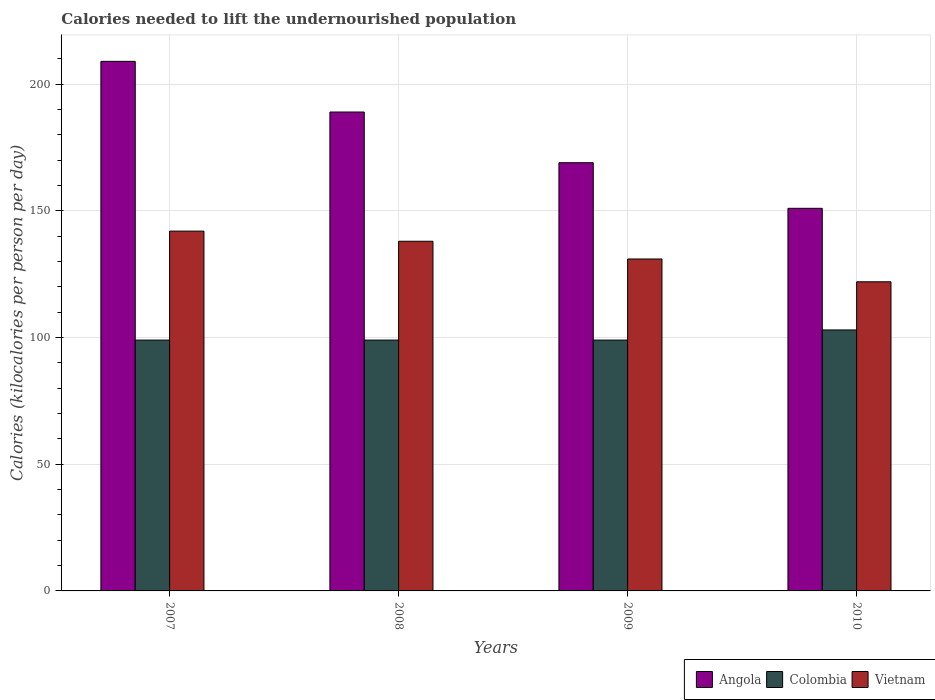How many different coloured bars are there?
Provide a succinct answer. 3. How many groups of bars are there?
Provide a short and direct response. 4. What is the label of the 3rd group of bars from the left?
Offer a terse response. 2009. In how many cases, is the number of bars for a given year not equal to the number of legend labels?
Provide a succinct answer. 0. What is the total calories needed to lift the undernourished population in Angola in 2009?
Ensure brevity in your answer.  169. Across all years, what is the maximum total calories needed to lift the undernourished population in Colombia?
Keep it short and to the point. 103. Across all years, what is the minimum total calories needed to lift the undernourished population in Vietnam?
Provide a short and direct response. 122. In which year was the total calories needed to lift the undernourished population in Angola maximum?
Your answer should be compact. 2007. In which year was the total calories needed to lift the undernourished population in Vietnam minimum?
Provide a succinct answer. 2010. What is the total total calories needed to lift the undernourished population in Vietnam in the graph?
Your response must be concise. 533. What is the difference between the total calories needed to lift the undernourished population in Vietnam in 2008 and that in 2009?
Your answer should be very brief. 7. What is the difference between the total calories needed to lift the undernourished population in Vietnam in 2007 and the total calories needed to lift the undernourished population in Angola in 2010?
Offer a terse response. -9. What is the average total calories needed to lift the undernourished population in Angola per year?
Give a very brief answer. 179.5. In the year 2008, what is the difference between the total calories needed to lift the undernourished population in Angola and total calories needed to lift the undernourished population in Vietnam?
Your answer should be very brief. 51. In how many years, is the total calories needed to lift the undernourished population in Angola greater than 160 kilocalories?
Keep it short and to the point. 3. What is the ratio of the total calories needed to lift the undernourished population in Colombia in 2008 to that in 2010?
Your answer should be compact. 0.96. Is the difference between the total calories needed to lift the undernourished population in Angola in 2009 and 2010 greater than the difference between the total calories needed to lift the undernourished population in Vietnam in 2009 and 2010?
Make the answer very short. Yes. What is the difference between the highest and the second highest total calories needed to lift the undernourished population in Angola?
Give a very brief answer. 20. What is the difference between the highest and the lowest total calories needed to lift the undernourished population in Vietnam?
Keep it short and to the point. 20. What does the 1st bar from the left in 2007 represents?
Keep it short and to the point. Angola. Is it the case that in every year, the sum of the total calories needed to lift the undernourished population in Vietnam and total calories needed to lift the undernourished population in Colombia is greater than the total calories needed to lift the undernourished population in Angola?
Make the answer very short. Yes. How many bars are there?
Make the answer very short. 12. Does the graph contain any zero values?
Offer a very short reply. No. Does the graph contain grids?
Provide a succinct answer. Yes. How many legend labels are there?
Your answer should be compact. 3. What is the title of the graph?
Ensure brevity in your answer.  Calories needed to lift the undernourished population. What is the label or title of the Y-axis?
Ensure brevity in your answer.  Calories (kilocalories per person per day). What is the Calories (kilocalories per person per day) in Angola in 2007?
Your response must be concise. 209. What is the Calories (kilocalories per person per day) in Vietnam in 2007?
Ensure brevity in your answer.  142. What is the Calories (kilocalories per person per day) in Angola in 2008?
Keep it short and to the point. 189. What is the Calories (kilocalories per person per day) of Colombia in 2008?
Offer a terse response. 99. What is the Calories (kilocalories per person per day) in Vietnam in 2008?
Keep it short and to the point. 138. What is the Calories (kilocalories per person per day) in Angola in 2009?
Your answer should be very brief. 169. What is the Calories (kilocalories per person per day) in Colombia in 2009?
Provide a short and direct response. 99. What is the Calories (kilocalories per person per day) in Vietnam in 2009?
Ensure brevity in your answer.  131. What is the Calories (kilocalories per person per day) in Angola in 2010?
Give a very brief answer. 151. What is the Calories (kilocalories per person per day) in Colombia in 2010?
Provide a short and direct response. 103. What is the Calories (kilocalories per person per day) in Vietnam in 2010?
Offer a very short reply. 122. Across all years, what is the maximum Calories (kilocalories per person per day) in Angola?
Keep it short and to the point. 209. Across all years, what is the maximum Calories (kilocalories per person per day) of Colombia?
Make the answer very short. 103. Across all years, what is the maximum Calories (kilocalories per person per day) of Vietnam?
Provide a succinct answer. 142. Across all years, what is the minimum Calories (kilocalories per person per day) of Angola?
Keep it short and to the point. 151. Across all years, what is the minimum Calories (kilocalories per person per day) in Colombia?
Offer a very short reply. 99. Across all years, what is the minimum Calories (kilocalories per person per day) of Vietnam?
Keep it short and to the point. 122. What is the total Calories (kilocalories per person per day) of Angola in the graph?
Give a very brief answer. 718. What is the total Calories (kilocalories per person per day) in Colombia in the graph?
Offer a very short reply. 400. What is the total Calories (kilocalories per person per day) in Vietnam in the graph?
Make the answer very short. 533. What is the difference between the Calories (kilocalories per person per day) of Angola in 2007 and that in 2008?
Provide a short and direct response. 20. What is the difference between the Calories (kilocalories per person per day) of Colombia in 2007 and that in 2008?
Make the answer very short. 0. What is the difference between the Calories (kilocalories per person per day) in Colombia in 2007 and that in 2009?
Your response must be concise. 0. What is the difference between the Calories (kilocalories per person per day) in Vietnam in 2007 and that in 2009?
Offer a terse response. 11. What is the difference between the Calories (kilocalories per person per day) of Colombia in 2007 and that in 2010?
Offer a very short reply. -4. What is the difference between the Calories (kilocalories per person per day) of Vietnam in 2007 and that in 2010?
Your response must be concise. 20. What is the difference between the Calories (kilocalories per person per day) of Vietnam in 2008 and that in 2009?
Offer a very short reply. 7. What is the difference between the Calories (kilocalories per person per day) in Vietnam in 2008 and that in 2010?
Give a very brief answer. 16. What is the difference between the Calories (kilocalories per person per day) of Colombia in 2009 and that in 2010?
Offer a very short reply. -4. What is the difference between the Calories (kilocalories per person per day) in Vietnam in 2009 and that in 2010?
Provide a succinct answer. 9. What is the difference between the Calories (kilocalories per person per day) of Angola in 2007 and the Calories (kilocalories per person per day) of Colombia in 2008?
Give a very brief answer. 110. What is the difference between the Calories (kilocalories per person per day) of Angola in 2007 and the Calories (kilocalories per person per day) of Vietnam in 2008?
Your answer should be very brief. 71. What is the difference between the Calories (kilocalories per person per day) in Colombia in 2007 and the Calories (kilocalories per person per day) in Vietnam in 2008?
Your response must be concise. -39. What is the difference between the Calories (kilocalories per person per day) of Angola in 2007 and the Calories (kilocalories per person per day) of Colombia in 2009?
Make the answer very short. 110. What is the difference between the Calories (kilocalories per person per day) of Angola in 2007 and the Calories (kilocalories per person per day) of Vietnam in 2009?
Your answer should be compact. 78. What is the difference between the Calories (kilocalories per person per day) of Colombia in 2007 and the Calories (kilocalories per person per day) of Vietnam in 2009?
Offer a very short reply. -32. What is the difference between the Calories (kilocalories per person per day) of Angola in 2007 and the Calories (kilocalories per person per day) of Colombia in 2010?
Keep it short and to the point. 106. What is the difference between the Calories (kilocalories per person per day) in Angola in 2007 and the Calories (kilocalories per person per day) in Vietnam in 2010?
Ensure brevity in your answer.  87. What is the difference between the Calories (kilocalories per person per day) of Angola in 2008 and the Calories (kilocalories per person per day) of Colombia in 2009?
Offer a very short reply. 90. What is the difference between the Calories (kilocalories per person per day) in Colombia in 2008 and the Calories (kilocalories per person per day) in Vietnam in 2009?
Give a very brief answer. -32. What is the difference between the Calories (kilocalories per person per day) in Angola in 2008 and the Calories (kilocalories per person per day) in Colombia in 2010?
Your response must be concise. 86. What is the difference between the Calories (kilocalories per person per day) in Colombia in 2008 and the Calories (kilocalories per person per day) in Vietnam in 2010?
Your response must be concise. -23. What is the average Calories (kilocalories per person per day) of Angola per year?
Your answer should be very brief. 179.5. What is the average Calories (kilocalories per person per day) of Colombia per year?
Provide a short and direct response. 100. What is the average Calories (kilocalories per person per day) in Vietnam per year?
Your response must be concise. 133.25. In the year 2007, what is the difference between the Calories (kilocalories per person per day) in Angola and Calories (kilocalories per person per day) in Colombia?
Keep it short and to the point. 110. In the year 2007, what is the difference between the Calories (kilocalories per person per day) of Angola and Calories (kilocalories per person per day) of Vietnam?
Your answer should be very brief. 67. In the year 2007, what is the difference between the Calories (kilocalories per person per day) in Colombia and Calories (kilocalories per person per day) in Vietnam?
Your answer should be compact. -43. In the year 2008, what is the difference between the Calories (kilocalories per person per day) of Angola and Calories (kilocalories per person per day) of Colombia?
Your answer should be very brief. 90. In the year 2008, what is the difference between the Calories (kilocalories per person per day) of Angola and Calories (kilocalories per person per day) of Vietnam?
Offer a very short reply. 51. In the year 2008, what is the difference between the Calories (kilocalories per person per day) of Colombia and Calories (kilocalories per person per day) of Vietnam?
Your answer should be compact. -39. In the year 2009, what is the difference between the Calories (kilocalories per person per day) in Angola and Calories (kilocalories per person per day) in Colombia?
Your response must be concise. 70. In the year 2009, what is the difference between the Calories (kilocalories per person per day) of Angola and Calories (kilocalories per person per day) of Vietnam?
Keep it short and to the point. 38. In the year 2009, what is the difference between the Calories (kilocalories per person per day) of Colombia and Calories (kilocalories per person per day) of Vietnam?
Make the answer very short. -32. In the year 2010, what is the difference between the Calories (kilocalories per person per day) in Angola and Calories (kilocalories per person per day) in Vietnam?
Offer a terse response. 29. What is the ratio of the Calories (kilocalories per person per day) in Angola in 2007 to that in 2008?
Ensure brevity in your answer.  1.11. What is the ratio of the Calories (kilocalories per person per day) of Colombia in 2007 to that in 2008?
Provide a succinct answer. 1. What is the ratio of the Calories (kilocalories per person per day) of Angola in 2007 to that in 2009?
Ensure brevity in your answer.  1.24. What is the ratio of the Calories (kilocalories per person per day) in Colombia in 2007 to that in 2009?
Provide a succinct answer. 1. What is the ratio of the Calories (kilocalories per person per day) of Vietnam in 2007 to that in 2009?
Provide a succinct answer. 1.08. What is the ratio of the Calories (kilocalories per person per day) of Angola in 2007 to that in 2010?
Give a very brief answer. 1.38. What is the ratio of the Calories (kilocalories per person per day) in Colombia in 2007 to that in 2010?
Provide a short and direct response. 0.96. What is the ratio of the Calories (kilocalories per person per day) in Vietnam in 2007 to that in 2010?
Give a very brief answer. 1.16. What is the ratio of the Calories (kilocalories per person per day) of Angola in 2008 to that in 2009?
Provide a short and direct response. 1.12. What is the ratio of the Calories (kilocalories per person per day) in Vietnam in 2008 to that in 2009?
Keep it short and to the point. 1.05. What is the ratio of the Calories (kilocalories per person per day) of Angola in 2008 to that in 2010?
Make the answer very short. 1.25. What is the ratio of the Calories (kilocalories per person per day) of Colombia in 2008 to that in 2010?
Your response must be concise. 0.96. What is the ratio of the Calories (kilocalories per person per day) in Vietnam in 2008 to that in 2010?
Your response must be concise. 1.13. What is the ratio of the Calories (kilocalories per person per day) of Angola in 2009 to that in 2010?
Ensure brevity in your answer.  1.12. What is the ratio of the Calories (kilocalories per person per day) in Colombia in 2009 to that in 2010?
Keep it short and to the point. 0.96. What is the ratio of the Calories (kilocalories per person per day) in Vietnam in 2009 to that in 2010?
Your answer should be compact. 1.07. What is the difference between the highest and the second highest Calories (kilocalories per person per day) of Angola?
Make the answer very short. 20. What is the difference between the highest and the second highest Calories (kilocalories per person per day) of Colombia?
Provide a short and direct response. 4. What is the difference between the highest and the second highest Calories (kilocalories per person per day) in Vietnam?
Offer a very short reply. 4. What is the difference between the highest and the lowest Calories (kilocalories per person per day) in Colombia?
Your answer should be compact. 4. 